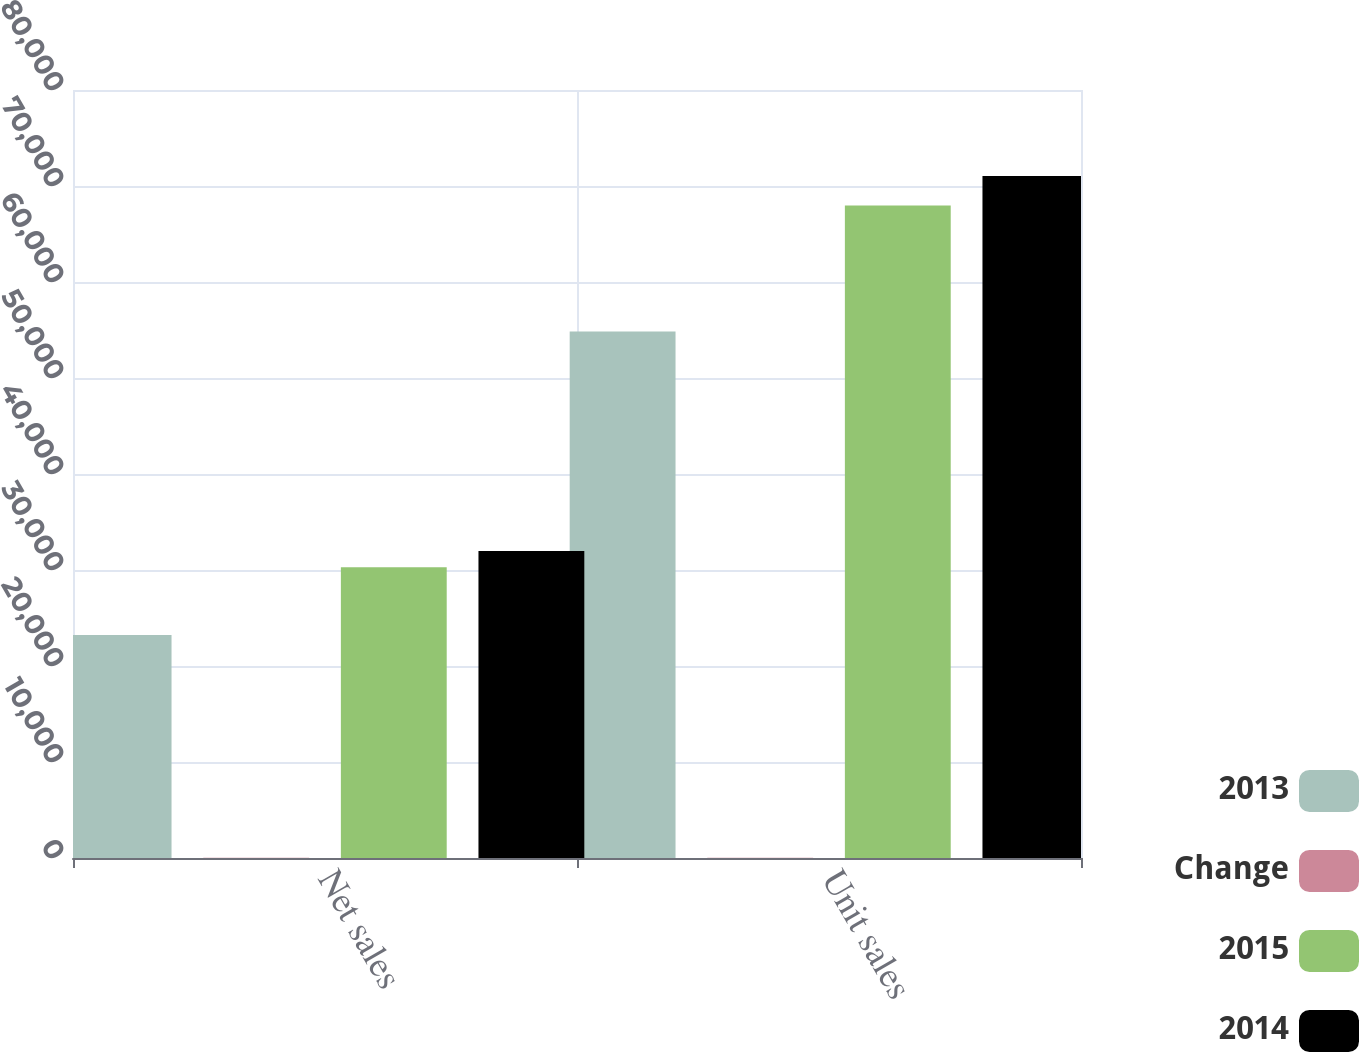<chart> <loc_0><loc_0><loc_500><loc_500><stacked_bar_chart><ecel><fcel>Net sales<fcel>Unit sales<nl><fcel>2013<fcel>23227<fcel>54856<nl><fcel>Change<fcel>23<fcel>19<nl><fcel>2015<fcel>30283<fcel>67977<nl><fcel>2014<fcel>31980<fcel>71033<nl></chart> 